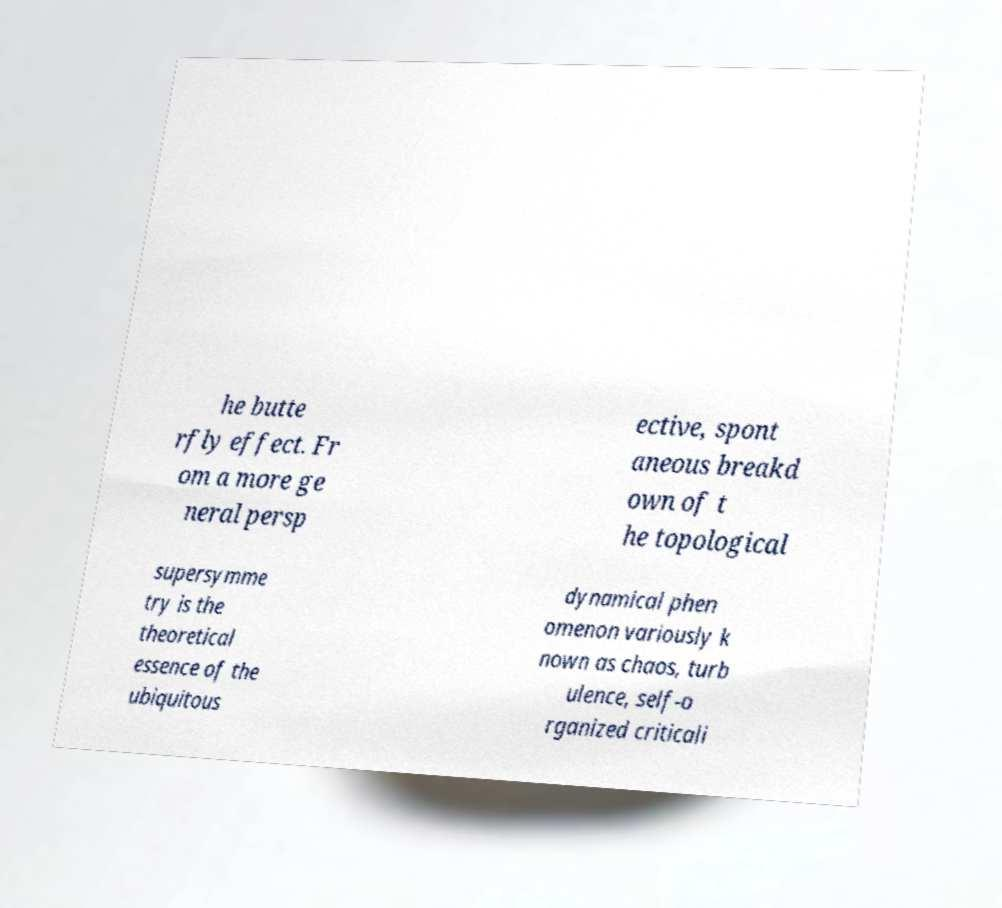Please identify and transcribe the text found in this image. he butte rfly effect. Fr om a more ge neral persp ective, spont aneous breakd own of t he topological supersymme try is the theoretical essence of the ubiquitous dynamical phen omenon variously k nown as chaos, turb ulence, self-o rganized criticali 